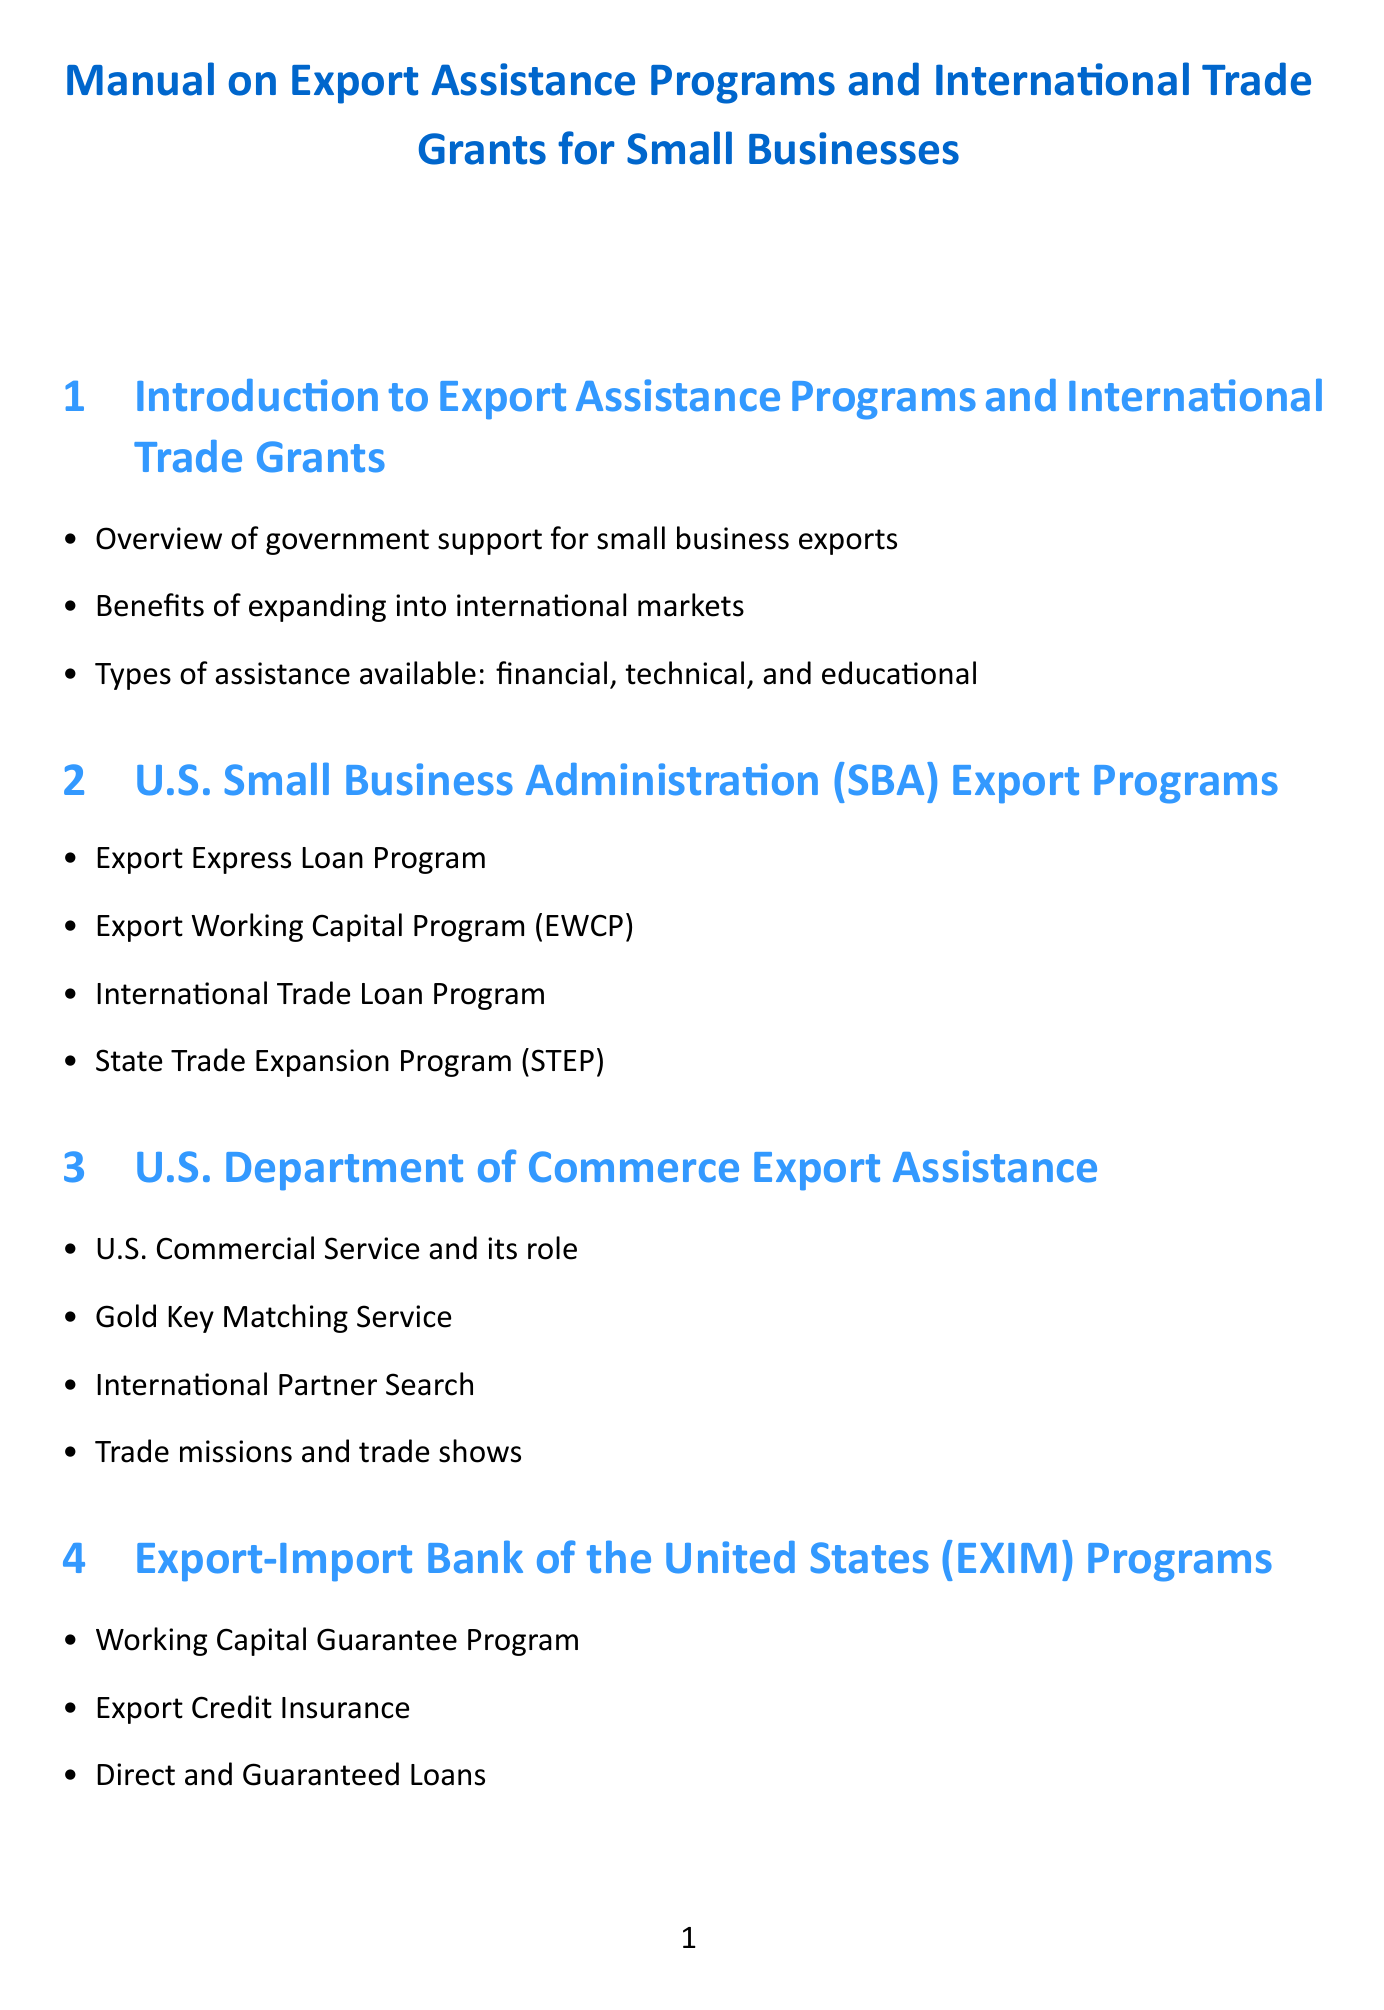What are the types of assistance available? The types of assistance mentioned include financial, technical, and educational.
Answer: financial, technical, and educational What is the role of the U.S. Commercial Service? The U.S. Commercial Service is discussed in the context of its role in providing export assistance to small businesses.
Answer: export assistance What program offers grants for state trade expansion? The State Trade Expansion Program (STEP) provides grants for state trade expansion.
Answer: State Trade Expansion Program (STEP) What does the Market Access Program (MAP) target? The Market Access Program (MAP) is associated with assisting businesses to access international markets.
Answer: international markets Which agency offers Export Credit Insurance? The Export-Import Bank of the United States (EXIM) offers Export Credit Insurance.
Answer: Export-Import Bank of the United States (EXIM) What are common mistakes to avoid in applications? The document specifies common mistakes that small businesses should avoid when applying for grants and assistance.
Answer: common mistakes How many case studies are presented? Three case studies of successful small business exporters are presented in the document.
Answer: three What is one of the digital tools mentioned for export assistance? The SBA's Export Business Planner tool is mentioned as a digital tool for export assistance.
Answer: SBA's Export Business Planner tool What kind of plan is suggested to maximize benefits? Developing an export business plan is suggested to maximize benefits from assistance programs.
Answer: export business plan 